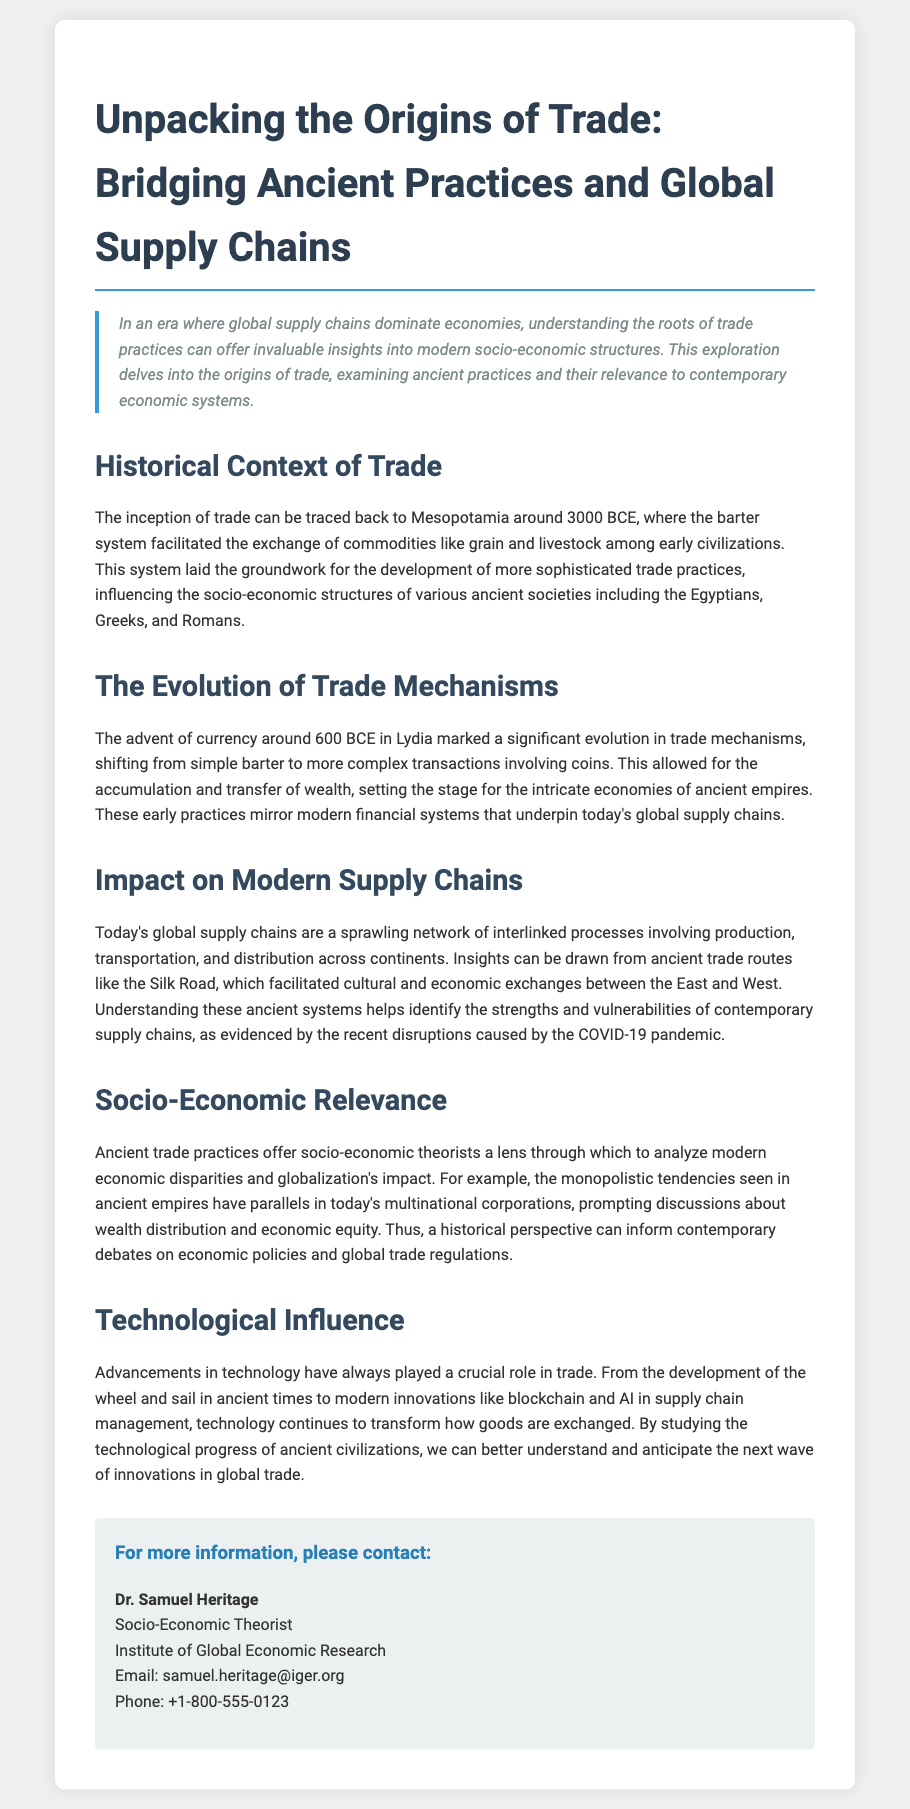What year is considered the inception of trade? The document states that the inception of trade can be traced back to Mesopotamia around 3000 BCE.
Answer: 3000 BCE What ancient civilization is mentioned alongside trade practices? The document mentions civilizations such as the Egyptians, Greeks, and Romans that were influenced by the early barter system.
Answer: Egyptians, Greeks, and Romans What significant evolution in trade mechanisms occurred around 600 BCE? According to the document, the advent of currency marked a significant evolution in trade mechanisms.
Answer: Currency What ancient trade route is referenced in relation to modern supply chains? The document refers to the Silk Road as an ancient trade route that facilitated exchanges between the East and West.
Answer: Silk Road What contemporary issue is highlighted regarding supply chains? The document mentions recent disruptions caused by the COVID-19 pandemic as a contemporary issue impacting supply chains.
Answer: COVID-19 Who is the contact person for more information? The document provides the name of Dr. Samuel Heritage as the contact person for further inquiries.
Answer: Dr. Samuel Heritage What role has technology played in trade, according to the document? The document discusses that advancements in technology have played a crucial role in the evolution and transformation of trade.
Answer: Crucial role What economic concept is related to ancient trade practices in the document? The document mentions wealth distribution and economic equity as key concepts in relation to ancient trade practices.
Answer: Wealth distribution and economic equity How is the document primarily categorized? The structure and content of the document classify it as a press release focused on trade origins and socio-economic analysis.
Answer: Press release 